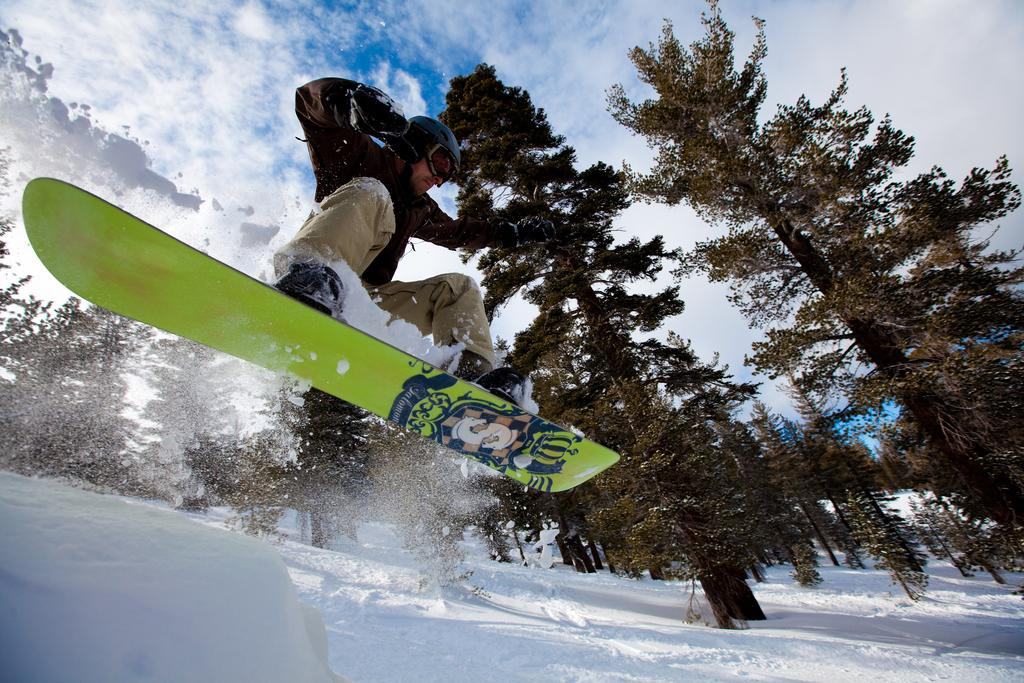What activity is the person in the image engaged in? The person is surfing on the snow in the image. What protective gear is the person wearing? The person is wearing a helmet. What can be seen in the background of the image? The sky, clouds, trees, and snow are visible in the background of the image. What type of hook can be seen attached to the person's cap in the image? There is no hook or cap present in the image; the person is wearing a helmet while surfing on the snow. 